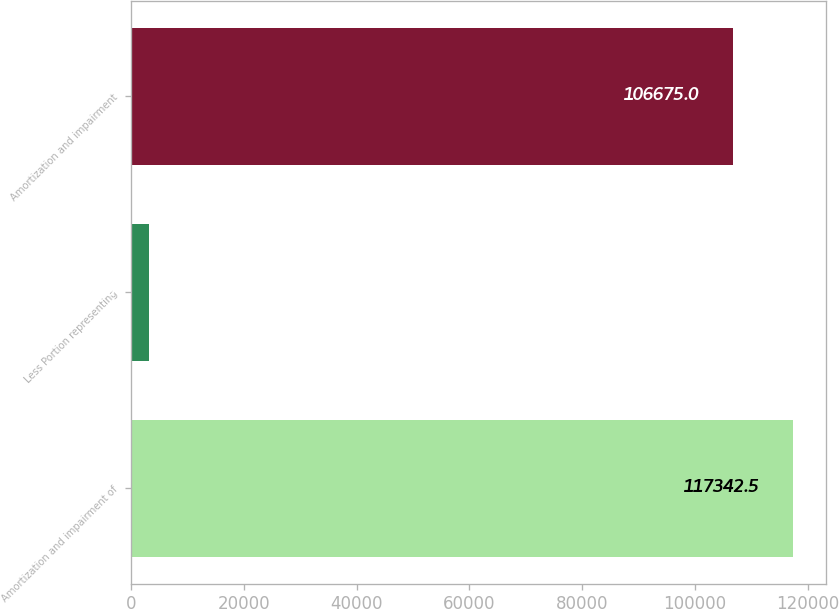<chart> <loc_0><loc_0><loc_500><loc_500><bar_chart><fcel>Amortization and impairment of<fcel>Less Portion representing<fcel>Amortization and impairment<nl><fcel>117342<fcel>3216<fcel>106675<nl></chart> 